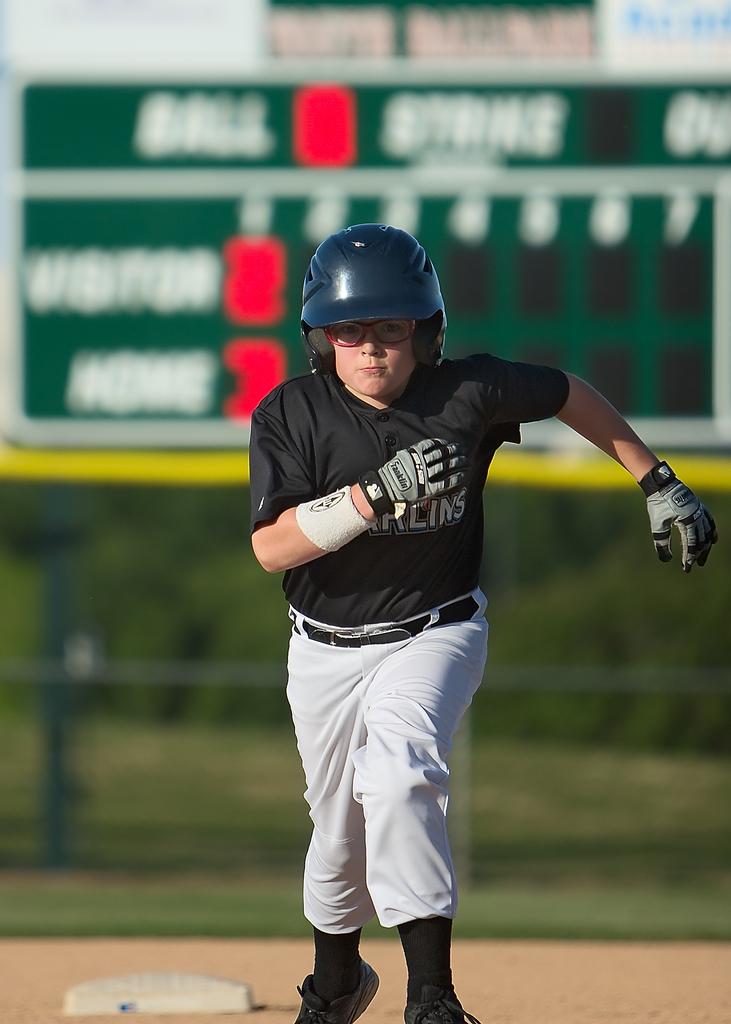What is the score of the home team?
Your answer should be compact. 3. What is the word wrote on the middle right beside strike?
Provide a succinct answer. Unanswerable. 